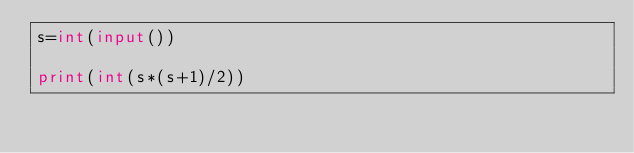Convert code to text. <code><loc_0><loc_0><loc_500><loc_500><_Python_>s=int(input())

print(int(s*(s+1)/2))</code> 